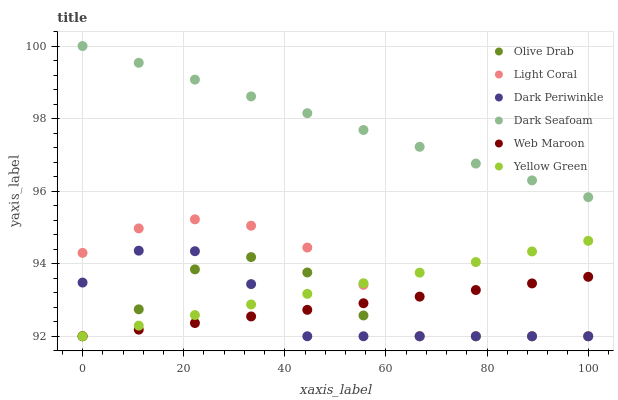Does Dark Periwinkle have the minimum area under the curve?
Answer yes or no. Yes. Does Dark Seafoam have the maximum area under the curve?
Answer yes or no. Yes. Does Web Maroon have the minimum area under the curve?
Answer yes or no. No. Does Web Maroon have the maximum area under the curve?
Answer yes or no. No. Is Yellow Green the smoothest?
Answer yes or no. Yes. Is Olive Drab the roughest?
Answer yes or no. Yes. Is Web Maroon the smoothest?
Answer yes or no. No. Is Web Maroon the roughest?
Answer yes or no. No. Does Yellow Green have the lowest value?
Answer yes or no. Yes. Does Dark Seafoam have the lowest value?
Answer yes or no. No. Does Dark Seafoam have the highest value?
Answer yes or no. Yes. Does Light Coral have the highest value?
Answer yes or no. No. Is Web Maroon less than Dark Seafoam?
Answer yes or no. Yes. Is Dark Seafoam greater than Dark Periwinkle?
Answer yes or no. Yes. Does Dark Periwinkle intersect Yellow Green?
Answer yes or no. Yes. Is Dark Periwinkle less than Yellow Green?
Answer yes or no. No. Is Dark Periwinkle greater than Yellow Green?
Answer yes or no. No. Does Web Maroon intersect Dark Seafoam?
Answer yes or no. No. 